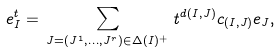<formula> <loc_0><loc_0><loc_500><loc_500>e _ { I } ^ { t } & = \, \sum _ { J = ( J ^ { 1 } , \dots , J ^ { r } ) \in \Delta ( I ) ^ { + } } \, t ^ { d ( I , J ) } c _ { ( I , J ) } e _ { J } ,</formula> 